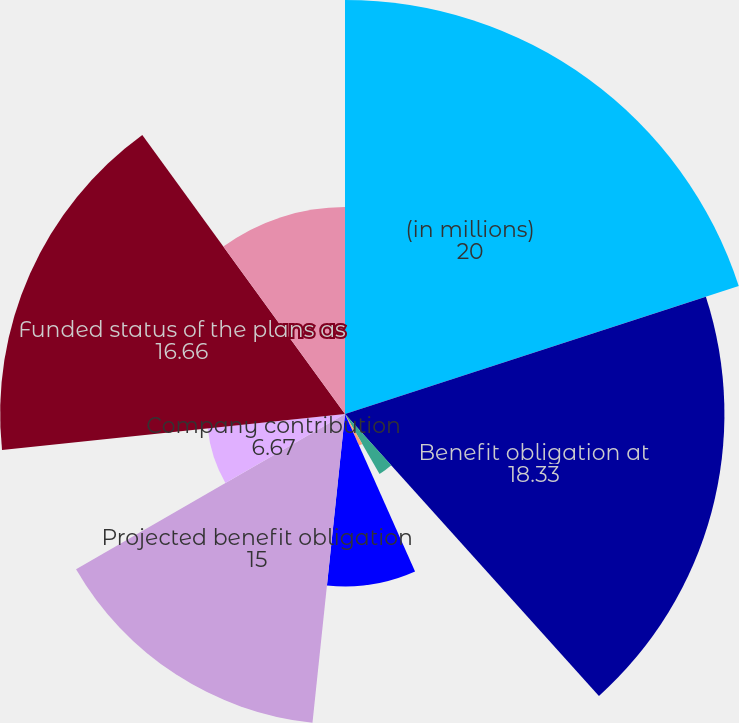Convert chart to OTSL. <chart><loc_0><loc_0><loc_500><loc_500><pie_chart><fcel>(in millions)<fcel>Benefit obligation at<fcel>Service cost<fcel>Interest cost<fcel>Actuarial loss<fcel>Benefits paid<fcel>Projected benefit obligation<fcel>Company contribution<fcel>Funded status of the plans as<fcel>Current liabilities<nl><fcel>20.0%<fcel>18.33%<fcel>0.0%<fcel>3.34%<fcel>1.67%<fcel>8.33%<fcel>15.0%<fcel>6.67%<fcel>16.66%<fcel>10.0%<nl></chart> 